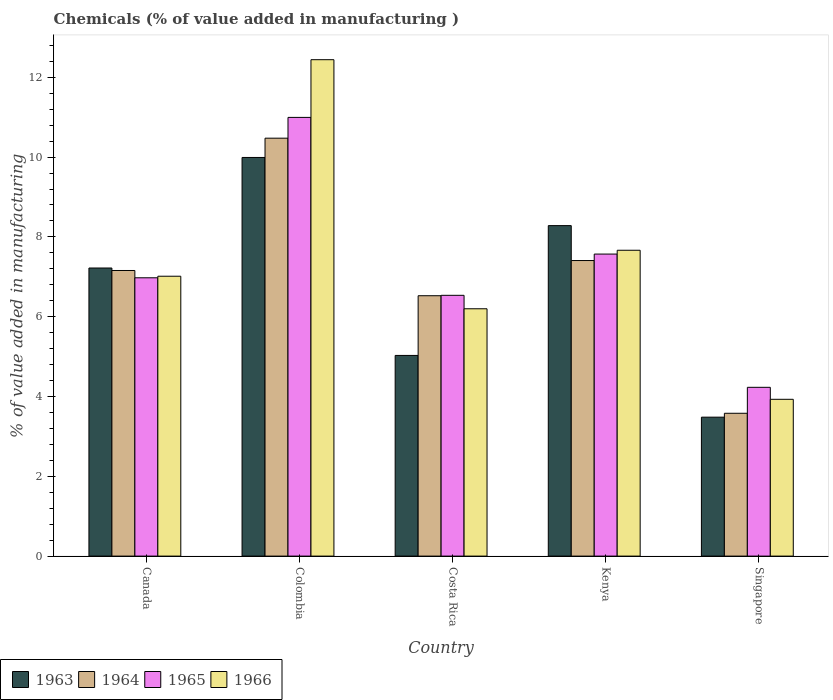How many different coloured bars are there?
Provide a succinct answer. 4. What is the label of the 5th group of bars from the left?
Your answer should be very brief. Singapore. In how many cases, is the number of bars for a given country not equal to the number of legend labels?
Ensure brevity in your answer.  0. What is the value added in manufacturing chemicals in 1963 in Costa Rica?
Provide a succinct answer. 5.03. Across all countries, what is the maximum value added in manufacturing chemicals in 1966?
Provide a short and direct response. 12.44. Across all countries, what is the minimum value added in manufacturing chemicals in 1965?
Give a very brief answer. 4.23. In which country was the value added in manufacturing chemicals in 1966 minimum?
Ensure brevity in your answer.  Singapore. What is the total value added in manufacturing chemicals in 1966 in the graph?
Ensure brevity in your answer.  37.25. What is the difference between the value added in manufacturing chemicals in 1966 in Kenya and that in Singapore?
Your answer should be very brief. 3.74. What is the difference between the value added in manufacturing chemicals in 1964 in Kenya and the value added in manufacturing chemicals in 1965 in Costa Rica?
Give a very brief answer. 0.87. What is the average value added in manufacturing chemicals in 1966 per country?
Ensure brevity in your answer.  7.45. What is the difference between the value added in manufacturing chemicals of/in 1966 and value added in manufacturing chemicals of/in 1964 in Kenya?
Make the answer very short. 0.26. What is the ratio of the value added in manufacturing chemicals in 1966 in Canada to that in Singapore?
Give a very brief answer. 1.78. Is the difference between the value added in manufacturing chemicals in 1966 in Colombia and Kenya greater than the difference between the value added in manufacturing chemicals in 1964 in Colombia and Kenya?
Ensure brevity in your answer.  Yes. What is the difference between the highest and the second highest value added in manufacturing chemicals in 1964?
Your response must be concise. 3.32. What is the difference between the highest and the lowest value added in manufacturing chemicals in 1965?
Make the answer very short. 6.76. Is the sum of the value added in manufacturing chemicals in 1964 in Canada and Colombia greater than the maximum value added in manufacturing chemicals in 1965 across all countries?
Provide a succinct answer. Yes. What does the 2nd bar from the left in Singapore represents?
Your response must be concise. 1964. What does the 3rd bar from the right in Costa Rica represents?
Give a very brief answer. 1964. How many countries are there in the graph?
Offer a very short reply. 5. What is the difference between two consecutive major ticks on the Y-axis?
Offer a terse response. 2. How many legend labels are there?
Give a very brief answer. 4. What is the title of the graph?
Provide a short and direct response. Chemicals (% of value added in manufacturing ). Does "1972" appear as one of the legend labels in the graph?
Your answer should be compact. No. What is the label or title of the Y-axis?
Offer a terse response. % of value added in manufacturing. What is the % of value added in manufacturing in 1963 in Canada?
Make the answer very short. 7.22. What is the % of value added in manufacturing of 1964 in Canada?
Keep it short and to the point. 7.16. What is the % of value added in manufacturing in 1965 in Canada?
Give a very brief answer. 6.98. What is the % of value added in manufacturing in 1966 in Canada?
Your response must be concise. 7.01. What is the % of value added in manufacturing in 1963 in Colombia?
Offer a very short reply. 9.99. What is the % of value added in manufacturing of 1964 in Colombia?
Provide a short and direct response. 10.47. What is the % of value added in manufacturing of 1965 in Colombia?
Provide a short and direct response. 10.99. What is the % of value added in manufacturing of 1966 in Colombia?
Give a very brief answer. 12.44. What is the % of value added in manufacturing of 1963 in Costa Rica?
Offer a terse response. 5.03. What is the % of value added in manufacturing in 1964 in Costa Rica?
Keep it short and to the point. 6.53. What is the % of value added in manufacturing of 1965 in Costa Rica?
Offer a terse response. 6.54. What is the % of value added in manufacturing of 1966 in Costa Rica?
Give a very brief answer. 6.2. What is the % of value added in manufacturing of 1963 in Kenya?
Make the answer very short. 8.28. What is the % of value added in manufacturing of 1964 in Kenya?
Offer a terse response. 7.41. What is the % of value added in manufacturing of 1965 in Kenya?
Provide a succinct answer. 7.57. What is the % of value added in manufacturing in 1966 in Kenya?
Offer a very short reply. 7.67. What is the % of value added in manufacturing in 1963 in Singapore?
Your answer should be compact. 3.48. What is the % of value added in manufacturing in 1964 in Singapore?
Offer a terse response. 3.58. What is the % of value added in manufacturing in 1965 in Singapore?
Offer a terse response. 4.23. What is the % of value added in manufacturing of 1966 in Singapore?
Provide a short and direct response. 3.93. Across all countries, what is the maximum % of value added in manufacturing in 1963?
Ensure brevity in your answer.  9.99. Across all countries, what is the maximum % of value added in manufacturing in 1964?
Provide a succinct answer. 10.47. Across all countries, what is the maximum % of value added in manufacturing of 1965?
Offer a terse response. 10.99. Across all countries, what is the maximum % of value added in manufacturing in 1966?
Provide a short and direct response. 12.44. Across all countries, what is the minimum % of value added in manufacturing in 1963?
Ensure brevity in your answer.  3.48. Across all countries, what is the minimum % of value added in manufacturing of 1964?
Provide a short and direct response. 3.58. Across all countries, what is the minimum % of value added in manufacturing of 1965?
Give a very brief answer. 4.23. Across all countries, what is the minimum % of value added in manufacturing in 1966?
Give a very brief answer. 3.93. What is the total % of value added in manufacturing in 1963 in the graph?
Keep it short and to the point. 34.01. What is the total % of value added in manufacturing in 1964 in the graph?
Ensure brevity in your answer.  35.15. What is the total % of value added in manufacturing of 1965 in the graph?
Provide a succinct answer. 36.31. What is the total % of value added in manufacturing of 1966 in the graph?
Ensure brevity in your answer.  37.25. What is the difference between the % of value added in manufacturing in 1963 in Canada and that in Colombia?
Offer a terse response. -2.77. What is the difference between the % of value added in manufacturing of 1964 in Canada and that in Colombia?
Provide a succinct answer. -3.32. What is the difference between the % of value added in manufacturing of 1965 in Canada and that in Colombia?
Your answer should be very brief. -4.02. What is the difference between the % of value added in manufacturing in 1966 in Canada and that in Colombia?
Your answer should be compact. -5.43. What is the difference between the % of value added in manufacturing in 1963 in Canada and that in Costa Rica?
Your response must be concise. 2.19. What is the difference between the % of value added in manufacturing in 1964 in Canada and that in Costa Rica?
Offer a very short reply. 0.63. What is the difference between the % of value added in manufacturing of 1965 in Canada and that in Costa Rica?
Provide a short and direct response. 0.44. What is the difference between the % of value added in manufacturing of 1966 in Canada and that in Costa Rica?
Offer a very short reply. 0.82. What is the difference between the % of value added in manufacturing of 1963 in Canada and that in Kenya?
Make the answer very short. -1.06. What is the difference between the % of value added in manufacturing of 1964 in Canada and that in Kenya?
Your answer should be compact. -0.25. What is the difference between the % of value added in manufacturing of 1965 in Canada and that in Kenya?
Give a very brief answer. -0.59. What is the difference between the % of value added in manufacturing in 1966 in Canada and that in Kenya?
Make the answer very short. -0.65. What is the difference between the % of value added in manufacturing in 1963 in Canada and that in Singapore?
Give a very brief answer. 3.74. What is the difference between the % of value added in manufacturing of 1964 in Canada and that in Singapore?
Ensure brevity in your answer.  3.58. What is the difference between the % of value added in manufacturing of 1965 in Canada and that in Singapore?
Offer a very short reply. 2.75. What is the difference between the % of value added in manufacturing in 1966 in Canada and that in Singapore?
Keep it short and to the point. 3.08. What is the difference between the % of value added in manufacturing in 1963 in Colombia and that in Costa Rica?
Make the answer very short. 4.96. What is the difference between the % of value added in manufacturing of 1964 in Colombia and that in Costa Rica?
Offer a very short reply. 3.95. What is the difference between the % of value added in manufacturing of 1965 in Colombia and that in Costa Rica?
Make the answer very short. 4.46. What is the difference between the % of value added in manufacturing of 1966 in Colombia and that in Costa Rica?
Provide a short and direct response. 6.24. What is the difference between the % of value added in manufacturing in 1963 in Colombia and that in Kenya?
Your answer should be very brief. 1.71. What is the difference between the % of value added in manufacturing in 1964 in Colombia and that in Kenya?
Provide a succinct answer. 3.07. What is the difference between the % of value added in manufacturing in 1965 in Colombia and that in Kenya?
Make the answer very short. 3.43. What is the difference between the % of value added in manufacturing of 1966 in Colombia and that in Kenya?
Your response must be concise. 4.78. What is the difference between the % of value added in manufacturing of 1963 in Colombia and that in Singapore?
Your response must be concise. 6.51. What is the difference between the % of value added in manufacturing in 1964 in Colombia and that in Singapore?
Give a very brief answer. 6.89. What is the difference between the % of value added in manufacturing of 1965 in Colombia and that in Singapore?
Your answer should be compact. 6.76. What is the difference between the % of value added in manufacturing of 1966 in Colombia and that in Singapore?
Provide a short and direct response. 8.51. What is the difference between the % of value added in manufacturing in 1963 in Costa Rica and that in Kenya?
Provide a succinct answer. -3.25. What is the difference between the % of value added in manufacturing in 1964 in Costa Rica and that in Kenya?
Offer a terse response. -0.88. What is the difference between the % of value added in manufacturing in 1965 in Costa Rica and that in Kenya?
Provide a succinct answer. -1.03. What is the difference between the % of value added in manufacturing in 1966 in Costa Rica and that in Kenya?
Offer a very short reply. -1.47. What is the difference between the % of value added in manufacturing in 1963 in Costa Rica and that in Singapore?
Your response must be concise. 1.55. What is the difference between the % of value added in manufacturing in 1964 in Costa Rica and that in Singapore?
Your response must be concise. 2.95. What is the difference between the % of value added in manufacturing of 1965 in Costa Rica and that in Singapore?
Provide a short and direct response. 2.31. What is the difference between the % of value added in manufacturing in 1966 in Costa Rica and that in Singapore?
Give a very brief answer. 2.27. What is the difference between the % of value added in manufacturing in 1963 in Kenya and that in Singapore?
Ensure brevity in your answer.  4.8. What is the difference between the % of value added in manufacturing in 1964 in Kenya and that in Singapore?
Offer a terse response. 3.83. What is the difference between the % of value added in manufacturing of 1965 in Kenya and that in Singapore?
Your answer should be very brief. 3.34. What is the difference between the % of value added in manufacturing in 1966 in Kenya and that in Singapore?
Your answer should be very brief. 3.74. What is the difference between the % of value added in manufacturing of 1963 in Canada and the % of value added in manufacturing of 1964 in Colombia?
Give a very brief answer. -3.25. What is the difference between the % of value added in manufacturing of 1963 in Canada and the % of value added in manufacturing of 1965 in Colombia?
Give a very brief answer. -3.77. What is the difference between the % of value added in manufacturing in 1963 in Canada and the % of value added in manufacturing in 1966 in Colombia?
Keep it short and to the point. -5.22. What is the difference between the % of value added in manufacturing in 1964 in Canada and the % of value added in manufacturing in 1965 in Colombia?
Your answer should be compact. -3.84. What is the difference between the % of value added in manufacturing of 1964 in Canada and the % of value added in manufacturing of 1966 in Colombia?
Give a very brief answer. -5.28. What is the difference between the % of value added in manufacturing in 1965 in Canada and the % of value added in manufacturing in 1966 in Colombia?
Keep it short and to the point. -5.47. What is the difference between the % of value added in manufacturing in 1963 in Canada and the % of value added in manufacturing in 1964 in Costa Rica?
Provide a short and direct response. 0.69. What is the difference between the % of value added in manufacturing in 1963 in Canada and the % of value added in manufacturing in 1965 in Costa Rica?
Your answer should be compact. 0.68. What is the difference between the % of value added in manufacturing in 1963 in Canada and the % of value added in manufacturing in 1966 in Costa Rica?
Offer a very short reply. 1.02. What is the difference between the % of value added in manufacturing in 1964 in Canada and the % of value added in manufacturing in 1965 in Costa Rica?
Provide a short and direct response. 0.62. What is the difference between the % of value added in manufacturing in 1964 in Canada and the % of value added in manufacturing in 1966 in Costa Rica?
Keep it short and to the point. 0.96. What is the difference between the % of value added in manufacturing of 1965 in Canada and the % of value added in manufacturing of 1966 in Costa Rica?
Keep it short and to the point. 0.78. What is the difference between the % of value added in manufacturing in 1963 in Canada and the % of value added in manufacturing in 1964 in Kenya?
Provide a short and direct response. -0.19. What is the difference between the % of value added in manufacturing in 1963 in Canada and the % of value added in manufacturing in 1965 in Kenya?
Keep it short and to the point. -0.35. What is the difference between the % of value added in manufacturing in 1963 in Canada and the % of value added in manufacturing in 1966 in Kenya?
Your answer should be compact. -0.44. What is the difference between the % of value added in manufacturing of 1964 in Canada and the % of value added in manufacturing of 1965 in Kenya?
Your answer should be compact. -0.41. What is the difference between the % of value added in manufacturing in 1964 in Canada and the % of value added in manufacturing in 1966 in Kenya?
Offer a terse response. -0.51. What is the difference between the % of value added in manufacturing of 1965 in Canada and the % of value added in manufacturing of 1966 in Kenya?
Provide a short and direct response. -0.69. What is the difference between the % of value added in manufacturing of 1963 in Canada and the % of value added in manufacturing of 1964 in Singapore?
Provide a succinct answer. 3.64. What is the difference between the % of value added in manufacturing in 1963 in Canada and the % of value added in manufacturing in 1965 in Singapore?
Offer a terse response. 2.99. What is the difference between the % of value added in manufacturing in 1963 in Canada and the % of value added in manufacturing in 1966 in Singapore?
Give a very brief answer. 3.29. What is the difference between the % of value added in manufacturing of 1964 in Canada and the % of value added in manufacturing of 1965 in Singapore?
Give a very brief answer. 2.93. What is the difference between the % of value added in manufacturing in 1964 in Canada and the % of value added in manufacturing in 1966 in Singapore?
Provide a succinct answer. 3.23. What is the difference between the % of value added in manufacturing of 1965 in Canada and the % of value added in manufacturing of 1966 in Singapore?
Your answer should be very brief. 3.05. What is the difference between the % of value added in manufacturing of 1963 in Colombia and the % of value added in manufacturing of 1964 in Costa Rica?
Make the answer very short. 3.47. What is the difference between the % of value added in manufacturing in 1963 in Colombia and the % of value added in manufacturing in 1965 in Costa Rica?
Offer a very short reply. 3.46. What is the difference between the % of value added in manufacturing in 1963 in Colombia and the % of value added in manufacturing in 1966 in Costa Rica?
Provide a succinct answer. 3.79. What is the difference between the % of value added in manufacturing in 1964 in Colombia and the % of value added in manufacturing in 1965 in Costa Rica?
Keep it short and to the point. 3.94. What is the difference between the % of value added in manufacturing in 1964 in Colombia and the % of value added in manufacturing in 1966 in Costa Rica?
Offer a very short reply. 4.28. What is the difference between the % of value added in manufacturing in 1965 in Colombia and the % of value added in manufacturing in 1966 in Costa Rica?
Your response must be concise. 4.8. What is the difference between the % of value added in manufacturing in 1963 in Colombia and the % of value added in manufacturing in 1964 in Kenya?
Your answer should be very brief. 2.58. What is the difference between the % of value added in manufacturing of 1963 in Colombia and the % of value added in manufacturing of 1965 in Kenya?
Your response must be concise. 2.42. What is the difference between the % of value added in manufacturing of 1963 in Colombia and the % of value added in manufacturing of 1966 in Kenya?
Ensure brevity in your answer.  2.33. What is the difference between the % of value added in manufacturing of 1964 in Colombia and the % of value added in manufacturing of 1965 in Kenya?
Give a very brief answer. 2.9. What is the difference between the % of value added in manufacturing of 1964 in Colombia and the % of value added in manufacturing of 1966 in Kenya?
Provide a succinct answer. 2.81. What is the difference between the % of value added in manufacturing in 1965 in Colombia and the % of value added in manufacturing in 1966 in Kenya?
Offer a terse response. 3.33. What is the difference between the % of value added in manufacturing of 1963 in Colombia and the % of value added in manufacturing of 1964 in Singapore?
Offer a very short reply. 6.41. What is the difference between the % of value added in manufacturing in 1963 in Colombia and the % of value added in manufacturing in 1965 in Singapore?
Give a very brief answer. 5.76. What is the difference between the % of value added in manufacturing in 1963 in Colombia and the % of value added in manufacturing in 1966 in Singapore?
Ensure brevity in your answer.  6.06. What is the difference between the % of value added in manufacturing of 1964 in Colombia and the % of value added in manufacturing of 1965 in Singapore?
Offer a terse response. 6.24. What is the difference between the % of value added in manufacturing of 1964 in Colombia and the % of value added in manufacturing of 1966 in Singapore?
Make the answer very short. 6.54. What is the difference between the % of value added in manufacturing in 1965 in Colombia and the % of value added in manufacturing in 1966 in Singapore?
Offer a terse response. 7.07. What is the difference between the % of value added in manufacturing of 1963 in Costa Rica and the % of value added in manufacturing of 1964 in Kenya?
Offer a terse response. -2.38. What is the difference between the % of value added in manufacturing in 1963 in Costa Rica and the % of value added in manufacturing in 1965 in Kenya?
Your answer should be compact. -2.54. What is the difference between the % of value added in manufacturing of 1963 in Costa Rica and the % of value added in manufacturing of 1966 in Kenya?
Your answer should be compact. -2.64. What is the difference between the % of value added in manufacturing of 1964 in Costa Rica and the % of value added in manufacturing of 1965 in Kenya?
Ensure brevity in your answer.  -1.04. What is the difference between the % of value added in manufacturing of 1964 in Costa Rica and the % of value added in manufacturing of 1966 in Kenya?
Provide a short and direct response. -1.14. What is the difference between the % of value added in manufacturing in 1965 in Costa Rica and the % of value added in manufacturing in 1966 in Kenya?
Give a very brief answer. -1.13. What is the difference between the % of value added in manufacturing of 1963 in Costa Rica and the % of value added in manufacturing of 1964 in Singapore?
Your response must be concise. 1.45. What is the difference between the % of value added in manufacturing of 1963 in Costa Rica and the % of value added in manufacturing of 1965 in Singapore?
Make the answer very short. 0.8. What is the difference between the % of value added in manufacturing of 1963 in Costa Rica and the % of value added in manufacturing of 1966 in Singapore?
Your answer should be very brief. 1.1. What is the difference between the % of value added in manufacturing in 1964 in Costa Rica and the % of value added in manufacturing in 1965 in Singapore?
Offer a terse response. 2.3. What is the difference between the % of value added in manufacturing in 1964 in Costa Rica and the % of value added in manufacturing in 1966 in Singapore?
Ensure brevity in your answer.  2.6. What is the difference between the % of value added in manufacturing in 1965 in Costa Rica and the % of value added in manufacturing in 1966 in Singapore?
Your answer should be compact. 2.61. What is the difference between the % of value added in manufacturing of 1963 in Kenya and the % of value added in manufacturing of 1964 in Singapore?
Make the answer very short. 4.7. What is the difference between the % of value added in manufacturing in 1963 in Kenya and the % of value added in manufacturing in 1965 in Singapore?
Your response must be concise. 4.05. What is the difference between the % of value added in manufacturing in 1963 in Kenya and the % of value added in manufacturing in 1966 in Singapore?
Provide a short and direct response. 4.35. What is the difference between the % of value added in manufacturing in 1964 in Kenya and the % of value added in manufacturing in 1965 in Singapore?
Offer a terse response. 3.18. What is the difference between the % of value added in manufacturing in 1964 in Kenya and the % of value added in manufacturing in 1966 in Singapore?
Provide a succinct answer. 3.48. What is the difference between the % of value added in manufacturing of 1965 in Kenya and the % of value added in manufacturing of 1966 in Singapore?
Provide a succinct answer. 3.64. What is the average % of value added in manufacturing of 1963 per country?
Your answer should be very brief. 6.8. What is the average % of value added in manufacturing in 1964 per country?
Offer a terse response. 7.03. What is the average % of value added in manufacturing in 1965 per country?
Your response must be concise. 7.26. What is the average % of value added in manufacturing of 1966 per country?
Provide a short and direct response. 7.45. What is the difference between the % of value added in manufacturing of 1963 and % of value added in manufacturing of 1964 in Canada?
Your answer should be compact. 0.06. What is the difference between the % of value added in manufacturing of 1963 and % of value added in manufacturing of 1965 in Canada?
Provide a succinct answer. 0.25. What is the difference between the % of value added in manufacturing in 1963 and % of value added in manufacturing in 1966 in Canada?
Offer a very short reply. 0.21. What is the difference between the % of value added in manufacturing in 1964 and % of value added in manufacturing in 1965 in Canada?
Your answer should be compact. 0.18. What is the difference between the % of value added in manufacturing in 1964 and % of value added in manufacturing in 1966 in Canada?
Your answer should be compact. 0.14. What is the difference between the % of value added in manufacturing in 1965 and % of value added in manufacturing in 1966 in Canada?
Provide a succinct answer. -0.04. What is the difference between the % of value added in manufacturing in 1963 and % of value added in manufacturing in 1964 in Colombia?
Your answer should be compact. -0.48. What is the difference between the % of value added in manufacturing of 1963 and % of value added in manufacturing of 1965 in Colombia?
Give a very brief answer. -1. What is the difference between the % of value added in manufacturing in 1963 and % of value added in manufacturing in 1966 in Colombia?
Provide a short and direct response. -2.45. What is the difference between the % of value added in manufacturing in 1964 and % of value added in manufacturing in 1965 in Colombia?
Your answer should be very brief. -0.52. What is the difference between the % of value added in manufacturing in 1964 and % of value added in manufacturing in 1966 in Colombia?
Your response must be concise. -1.97. What is the difference between the % of value added in manufacturing of 1965 and % of value added in manufacturing of 1966 in Colombia?
Keep it short and to the point. -1.45. What is the difference between the % of value added in manufacturing in 1963 and % of value added in manufacturing in 1964 in Costa Rica?
Your answer should be very brief. -1.5. What is the difference between the % of value added in manufacturing of 1963 and % of value added in manufacturing of 1965 in Costa Rica?
Provide a succinct answer. -1.51. What is the difference between the % of value added in manufacturing in 1963 and % of value added in manufacturing in 1966 in Costa Rica?
Your answer should be compact. -1.17. What is the difference between the % of value added in manufacturing of 1964 and % of value added in manufacturing of 1965 in Costa Rica?
Your answer should be compact. -0.01. What is the difference between the % of value added in manufacturing of 1964 and % of value added in manufacturing of 1966 in Costa Rica?
Provide a succinct answer. 0.33. What is the difference between the % of value added in manufacturing of 1965 and % of value added in manufacturing of 1966 in Costa Rica?
Your answer should be compact. 0.34. What is the difference between the % of value added in manufacturing in 1963 and % of value added in manufacturing in 1964 in Kenya?
Offer a terse response. 0.87. What is the difference between the % of value added in manufacturing in 1963 and % of value added in manufacturing in 1965 in Kenya?
Your answer should be very brief. 0.71. What is the difference between the % of value added in manufacturing in 1963 and % of value added in manufacturing in 1966 in Kenya?
Your response must be concise. 0.62. What is the difference between the % of value added in manufacturing in 1964 and % of value added in manufacturing in 1965 in Kenya?
Your answer should be compact. -0.16. What is the difference between the % of value added in manufacturing of 1964 and % of value added in manufacturing of 1966 in Kenya?
Provide a succinct answer. -0.26. What is the difference between the % of value added in manufacturing in 1965 and % of value added in manufacturing in 1966 in Kenya?
Your answer should be compact. -0.1. What is the difference between the % of value added in manufacturing in 1963 and % of value added in manufacturing in 1964 in Singapore?
Keep it short and to the point. -0.1. What is the difference between the % of value added in manufacturing of 1963 and % of value added in manufacturing of 1965 in Singapore?
Keep it short and to the point. -0.75. What is the difference between the % of value added in manufacturing in 1963 and % of value added in manufacturing in 1966 in Singapore?
Offer a very short reply. -0.45. What is the difference between the % of value added in manufacturing of 1964 and % of value added in manufacturing of 1965 in Singapore?
Make the answer very short. -0.65. What is the difference between the % of value added in manufacturing in 1964 and % of value added in manufacturing in 1966 in Singapore?
Your answer should be compact. -0.35. What is the difference between the % of value added in manufacturing of 1965 and % of value added in manufacturing of 1966 in Singapore?
Provide a short and direct response. 0.3. What is the ratio of the % of value added in manufacturing of 1963 in Canada to that in Colombia?
Provide a short and direct response. 0.72. What is the ratio of the % of value added in manufacturing in 1964 in Canada to that in Colombia?
Keep it short and to the point. 0.68. What is the ratio of the % of value added in manufacturing of 1965 in Canada to that in Colombia?
Ensure brevity in your answer.  0.63. What is the ratio of the % of value added in manufacturing of 1966 in Canada to that in Colombia?
Make the answer very short. 0.56. What is the ratio of the % of value added in manufacturing of 1963 in Canada to that in Costa Rica?
Your answer should be very brief. 1.44. What is the ratio of the % of value added in manufacturing of 1964 in Canada to that in Costa Rica?
Make the answer very short. 1.1. What is the ratio of the % of value added in manufacturing of 1965 in Canada to that in Costa Rica?
Your response must be concise. 1.07. What is the ratio of the % of value added in manufacturing of 1966 in Canada to that in Costa Rica?
Ensure brevity in your answer.  1.13. What is the ratio of the % of value added in manufacturing in 1963 in Canada to that in Kenya?
Your response must be concise. 0.87. What is the ratio of the % of value added in manufacturing in 1964 in Canada to that in Kenya?
Give a very brief answer. 0.97. What is the ratio of the % of value added in manufacturing of 1965 in Canada to that in Kenya?
Offer a very short reply. 0.92. What is the ratio of the % of value added in manufacturing in 1966 in Canada to that in Kenya?
Your answer should be very brief. 0.92. What is the ratio of the % of value added in manufacturing in 1963 in Canada to that in Singapore?
Your response must be concise. 2.07. What is the ratio of the % of value added in manufacturing of 1964 in Canada to that in Singapore?
Offer a very short reply. 2. What is the ratio of the % of value added in manufacturing of 1965 in Canada to that in Singapore?
Your response must be concise. 1.65. What is the ratio of the % of value added in manufacturing in 1966 in Canada to that in Singapore?
Make the answer very short. 1.78. What is the ratio of the % of value added in manufacturing in 1963 in Colombia to that in Costa Rica?
Provide a short and direct response. 1.99. What is the ratio of the % of value added in manufacturing of 1964 in Colombia to that in Costa Rica?
Make the answer very short. 1.61. What is the ratio of the % of value added in manufacturing of 1965 in Colombia to that in Costa Rica?
Keep it short and to the point. 1.68. What is the ratio of the % of value added in manufacturing in 1966 in Colombia to that in Costa Rica?
Make the answer very short. 2.01. What is the ratio of the % of value added in manufacturing in 1963 in Colombia to that in Kenya?
Make the answer very short. 1.21. What is the ratio of the % of value added in manufacturing of 1964 in Colombia to that in Kenya?
Provide a succinct answer. 1.41. What is the ratio of the % of value added in manufacturing of 1965 in Colombia to that in Kenya?
Offer a terse response. 1.45. What is the ratio of the % of value added in manufacturing in 1966 in Colombia to that in Kenya?
Offer a very short reply. 1.62. What is the ratio of the % of value added in manufacturing of 1963 in Colombia to that in Singapore?
Provide a succinct answer. 2.87. What is the ratio of the % of value added in manufacturing in 1964 in Colombia to that in Singapore?
Give a very brief answer. 2.93. What is the ratio of the % of value added in manufacturing of 1965 in Colombia to that in Singapore?
Give a very brief answer. 2.6. What is the ratio of the % of value added in manufacturing in 1966 in Colombia to that in Singapore?
Your answer should be compact. 3.17. What is the ratio of the % of value added in manufacturing in 1963 in Costa Rica to that in Kenya?
Keep it short and to the point. 0.61. What is the ratio of the % of value added in manufacturing of 1964 in Costa Rica to that in Kenya?
Provide a short and direct response. 0.88. What is the ratio of the % of value added in manufacturing of 1965 in Costa Rica to that in Kenya?
Your answer should be compact. 0.86. What is the ratio of the % of value added in manufacturing of 1966 in Costa Rica to that in Kenya?
Offer a very short reply. 0.81. What is the ratio of the % of value added in manufacturing of 1963 in Costa Rica to that in Singapore?
Give a very brief answer. 1.44. What is the ratio of the % of value added in manufacturing in 1964 in Costa Rica to that in Singapore?
Your response must be concise. 1.82. What is the ratio of the % of value added in manufacturing of 1965 in Costa Rica to that in Singapore?
Give a very brief answer. 1.55. What is the ratio of the % of value added in manufacturing of 1966 in Costa Rica to that in Singapore?
Your answer should be compact. 1.58. What is the ratio of the % of value added in manufacturing in 1963 in Kenya to that in Singapore?
Give a very brief answer. 2.38. What is the ratio of the % of value added in manufacturing in 1964 in Kenya to that in Singapore?
Provide a succinct answer. 2.07. What is the ratio of the % of value added in manufacturing of 1965 in Kenya to that in Singapore?
Provide a succinct answer. 1.79. What is the ratio of the % of value added in manufacturing of 1966 in Kenya to that in Singapore?
Your response must be concise. 1.95. What is the difference between the highest and the second highest % of value added in manufacturing of 1963?
Provide a succinct answer. 1.71. What is the difference between the highest and the second highest % of value added in manufacturing of 1964?
Make the answer very short. 3.07. What is the difference between the highest and the second highest % of value added in manufacturing of 1965?
Offer a terse response. 3.43. What is the difference between the highest and the second highest % of value added in manufacturing in 1966?
Your answer should be compact. 4.78. What is the difference between the highest and the lowest % of value added in manufacturing of 1963?
Your answer should be compact. 6.51. What is the difference between the highest and the lowest % of value added in manufacturing of 1964?
Offer a terse response. 6.89. What is the difference between the highest and the lowest % of value added in manufacturing in 1965?
Keep it short and to the point. 6.76. What is the difference between the highest and the lowest % of value added in manufacturing in 1966?
Ensure brevity in your answer.  8.51. 